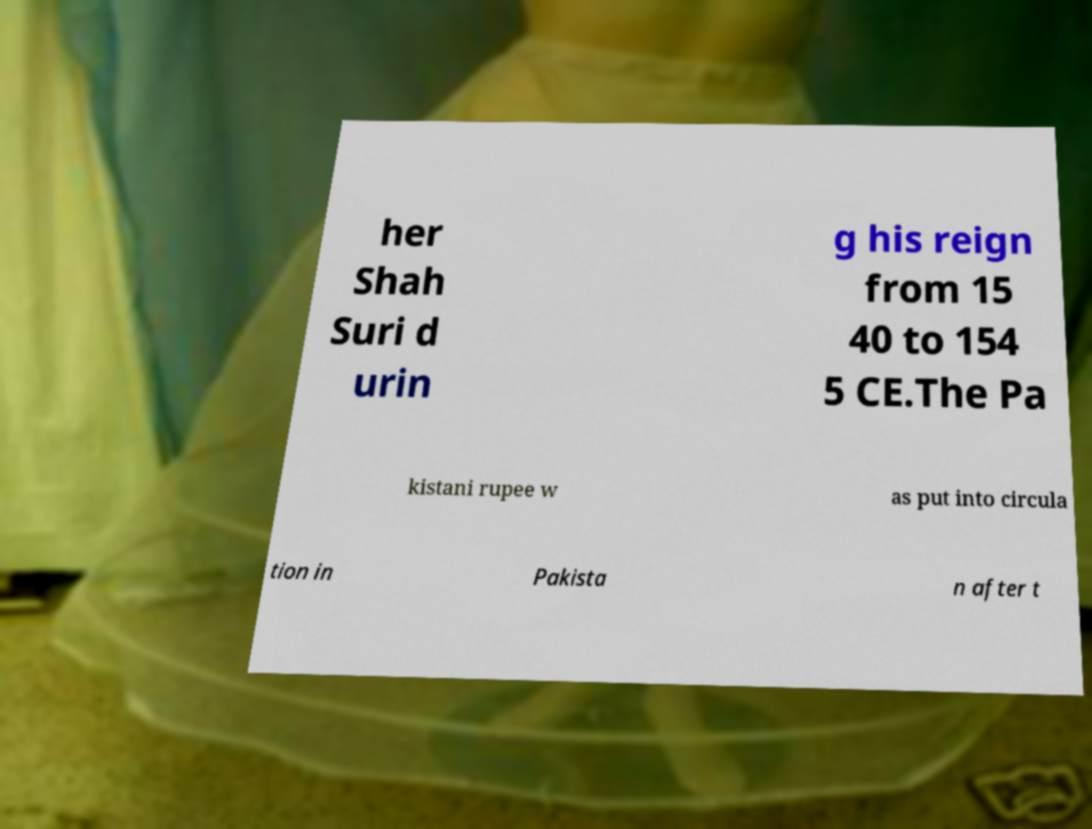I need the written content from this picture converted into text. Can you do that? her Shah Suri d urin g his reign from 15 40 to 154 5 CE.The Pa kistani rupee w as put into circula tion in Pakista n after t 